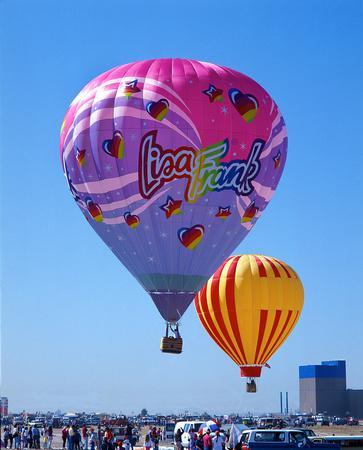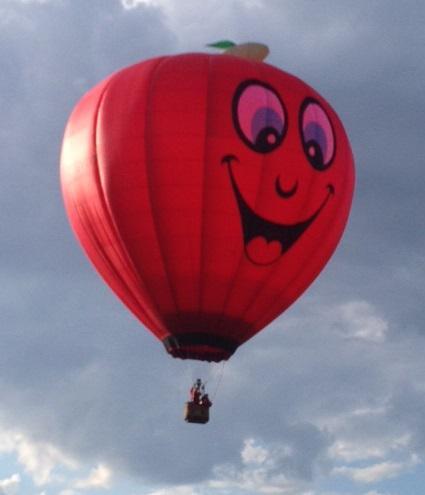The first image is the image on the left, the second image is the image on the right. Evaluate the accuracy of this statement regarding the images: "The left image balloon is supposed to look like a red apple.". Is it true? Answer yes or no. No. The first image is the image on the left, the second image is the image on the right. For the images shown, is this caption "One hot air balloon is on the ground and one is in the air." true? Answer yes or no. No. 